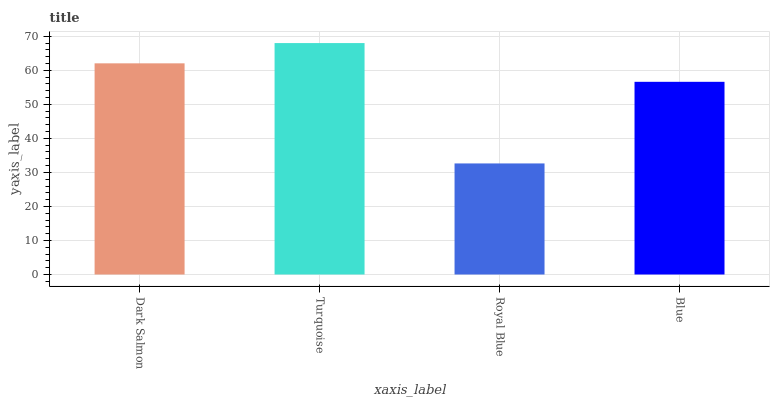Is Royal Blue the minimum?
Answer yes or no. Yes. Is Turquoise the maximum?
Answer yes or no. Yes. Is Turquoise the minimum?
Answer yes or no. No. Is Royal Blue the maximum?
Answer yes or no. No. Is Turquoise greater than Royal Blue?
Answer yes or no. Yes. Is Royal Blue less than Turquoise?
Answer yes or no. Yes. Is Royal Blue greater than Turquoise?
Answer yes or no. No. Is Turquoise less than Royal Blue?
Answer yes or no. No. Is Dark Salmon the high median?
Answer yes or no. Yes. Is Blue the low median?
Answer yes or no. Yes. Is Royal Blue the high median?
Answer yes or no. No. Is Turquoise the low median?
Answer yes or no. No. 